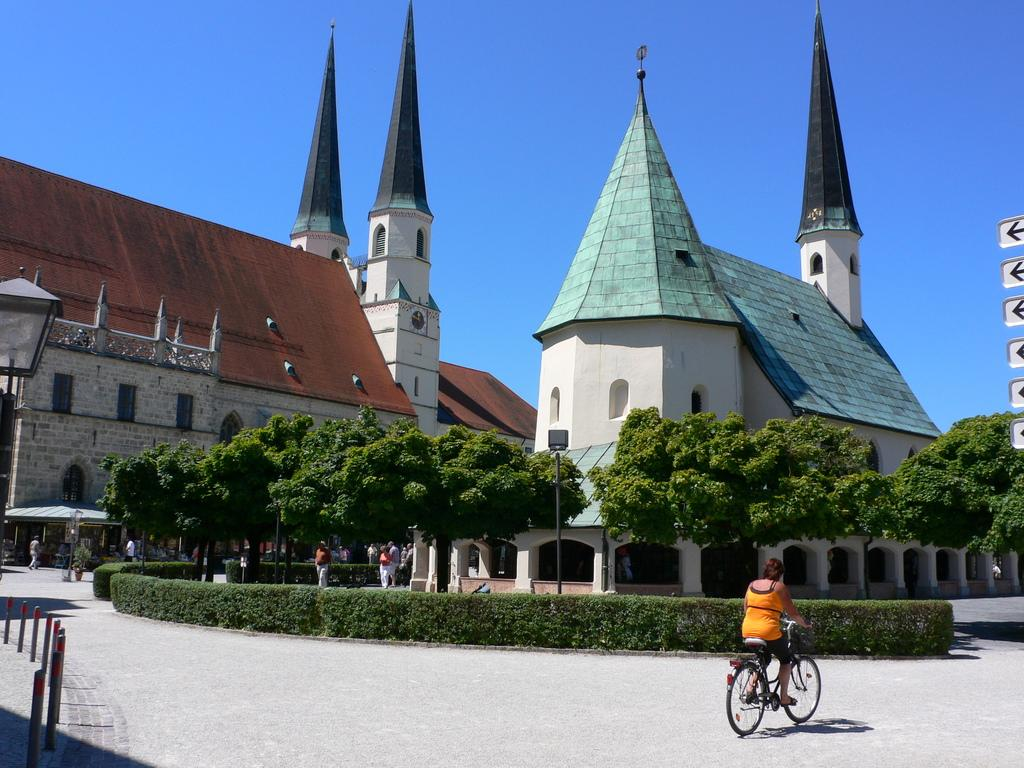What is the main subject of the image? There is a group of people in the image. Can you describe one person in the group? There is a woman in the image, and she is riding a bicycle. What type of vegetation can be seen in the image? Shrubs and trees are visible in the image. What type of structures are present in the image? There are buildings in the image. What type of oatmeal is being served at the event in the image? There is no event or oatmeal present in the image; it features a group of people, a woman riding a bicycle, and various natural and man-made elements. How much rice is visible in the image? There is no rice present in the image. 